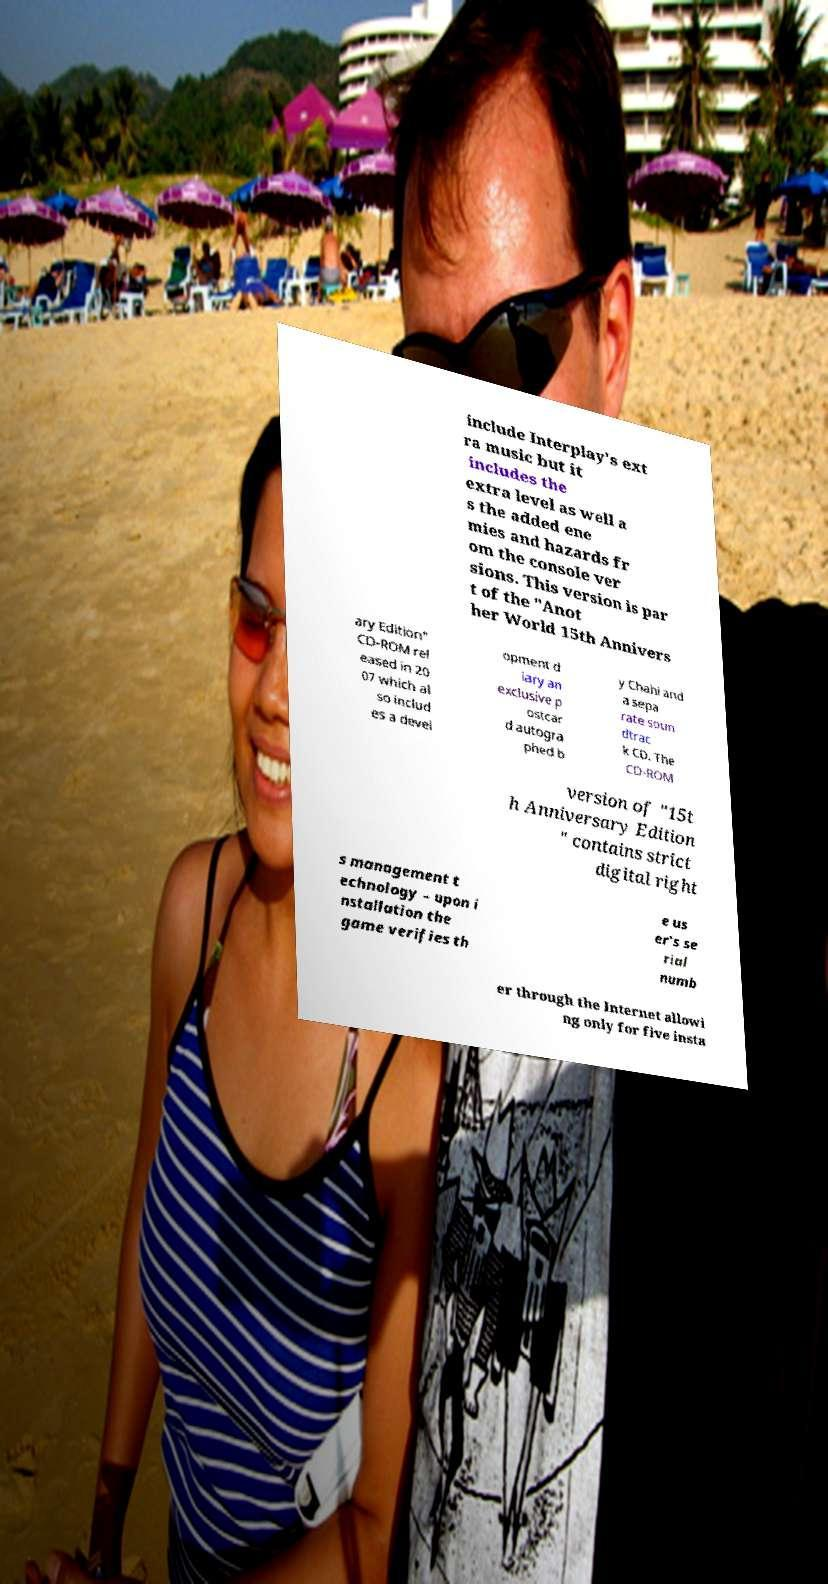Can you accurately transcribe the text from the provided image for me? include Interplay's ext ra music but it includes the extra level as well a s the added ene mies and hazards fr om the console ver sions. This version is par t of the "Anot her World 15th Annivers ary Edition" CD-ROM rel eased in 20 07 which al so includ es a devel opment d iary an exclusive p ostcar d autogra phed b y Chahi and a sepa rate soun dtrac k CD. The CD-ROM version of "15t h Anniversary Edition " contains strict digital right s management t echnology – upon i nstallation the game verifies th e us er's se rial numb er through the Internet allowi ng only for five insta 